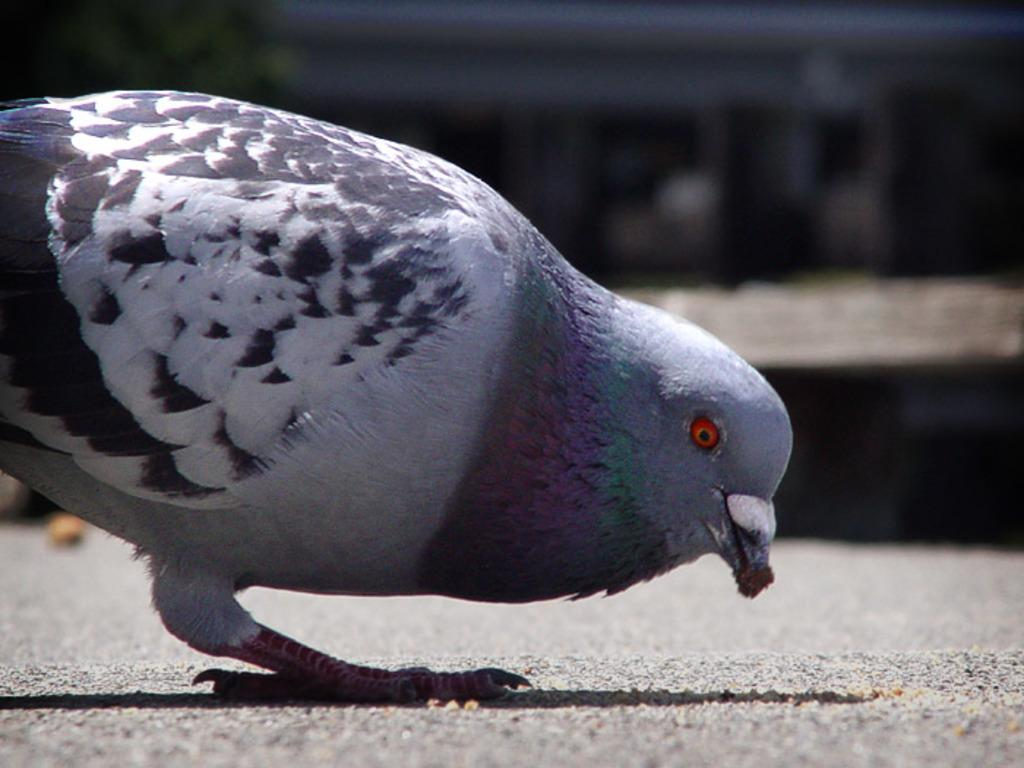What animal can be seen on the ground in the image? There is a pigeon on the ground in the image. Can you describe the background of the image? The background of the image is blurred. How many pigs are participating in the activity in the image? There are no pigs or activities present in the image; it features a pigeon on the ground and a blurred background. 